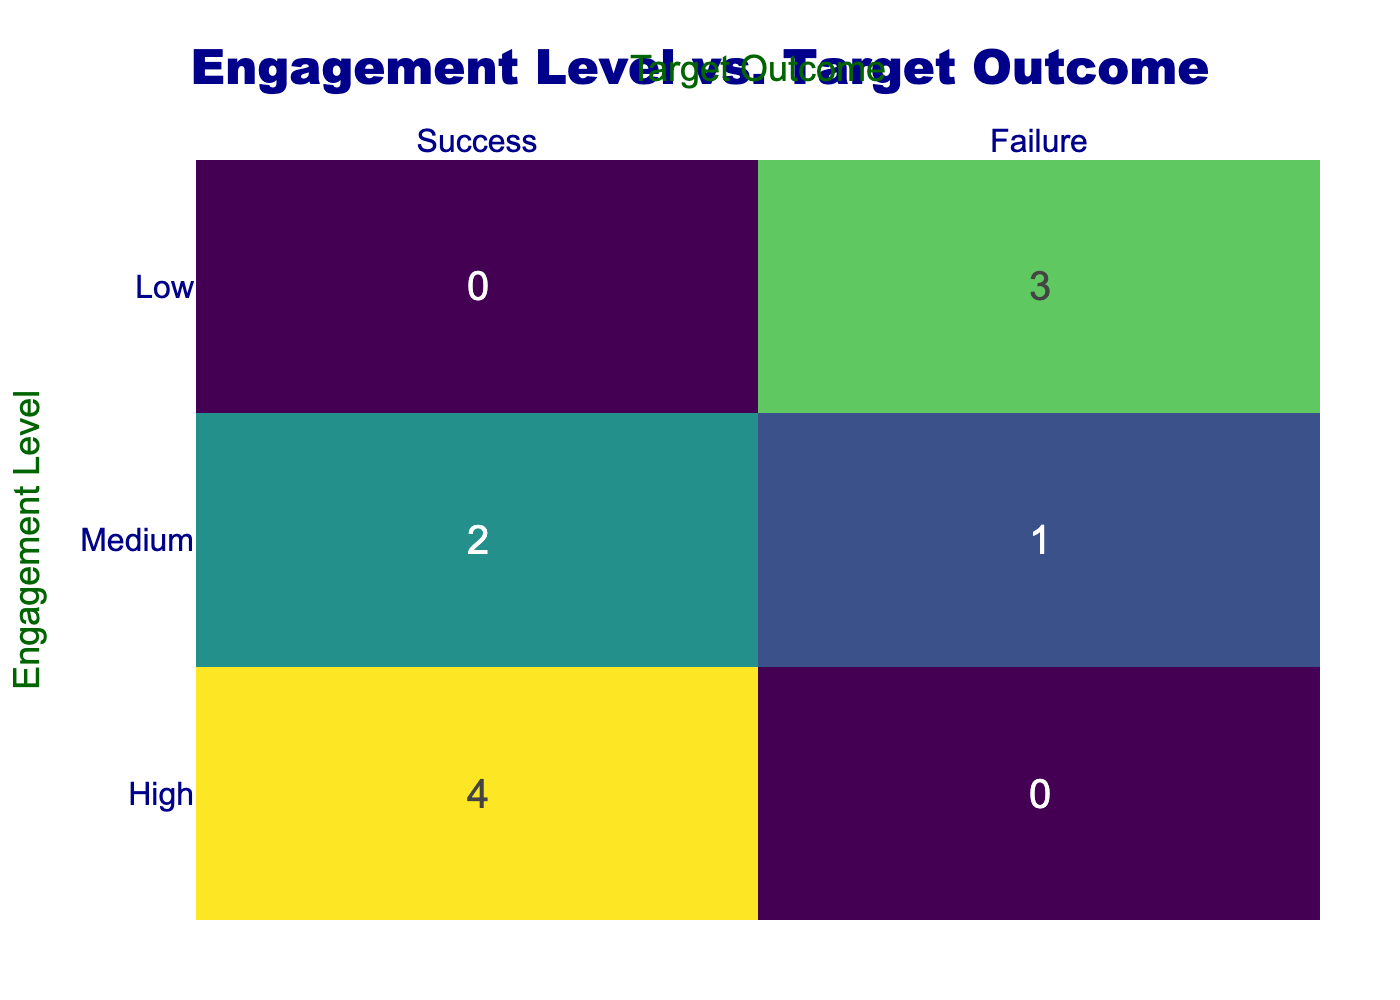What is the total number of users with a high engagement level? By looking at the confusion matrix, we can see the entry for "High" engagement is 4 (which corresponds to the "Success" outcome) plus the other outcomes, which are also listed in the same row. This gives us a total of 4 users for the high engagement level.
Answer: 4 How many users achieved success with medium engagement? Referring to the table, there is 1 entry under the "Medium" engagement level corresponding to "Success" ("Khan Academy").
Answer: 1 What is the total number of users classified as having low engagement? According to the table, for the "Low" engagement level, we can see there are 3 users (which are entries under "Failure") plus 0 under "Success" in the confusion matrix. Thus, the total number is 3.
Answer: 3 Is there any user with high engagement that failed? Here, the table shows that all users with high engagement ("Duolingo," "Quizlet," "ABCmouse," and "edX") achieved success. Therefore, the answer is no.
Answer: No What is the difference in the number of successes between high and medium engagement levels? From the matrix, we know there are 4 successes for "High" engagement and 1 success for "Medium" engagement. The difference between them is 4 - 1 = 3.
Answer: 3 If we consider only successful outcomes, what percentage of total users are classified as having high engagement? There are 4 successful outcomes (high engagement) and a total of 8 users. To find the percentage, we divide the number of high engagement users (4) by the total users (10) and multiply by 100. Thus, (4/10)*100 = 40%.
Answer: 40% What proportion of users with low engagement were successful? The table shows that there are 0 users with low engagement achieving success out of 3 total users with low engagement. To determine the proportion, we take 0 and divide it by 3, yielding 0/3 = 0, which indicates that none of the low engagement users were successful.
Answer: 0 How many total failures were recorded for users with medium engagement? Looking at the confusion matrix for "Medium" engagement, we see that there are 1 failure associated with this level, thus the total is 1.
Answer: 1 What is the total number of successful users across all engagement levels? The confusion matrix shows the total count of successful outcomes is 4 (high) + 1 (medium) + 0 (low) = 5 successful users overall.
Answer: 5 